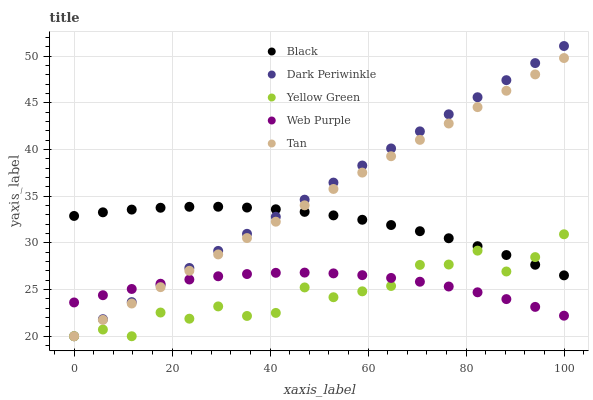Does Yellow Green have the minimum area under the curve?
Answer yes or no. Yes. Does Dark Periwinkle have the maximum area under the curve?
Answer yes or no. Yes. Does Web Purple have the minimum area under the curve?
Answer yes or no. No. Does Web Purple have the maximum area under the curve?
Answer yes or no. No. Is Dark Periwinkle the smoothest?
Answer yes or no. Yes. Is Yellow Green the roughest?
Answer yes or no. Yes. Is Web Purple the smoothest?
Answer yes or no. No. Is Web Purple the roughest?
Answer yes or no. No. Does Tan have the lowest value?
Answer yes or no. Yes. Does Web Purple have the lowest value?
Answer yes or no. No. Does Dark Periwinkle have the highest value?
Answer yes or no. Yes. Does Black have the highest value?
Answer yes or no. No. Is Web Purple less than Black?
Answer yes or no. Yes. Is Black greater than Web Purple?
Answer yes or no. Yes. Does Web Purple intersect Tan?
Answer yes or no. Yes. Is Web Purple less than Tan?
Answer yes or no. No. Is Web Purple greater than Tan?
Answer yes or no. No. Does Web Purple intersect Black?
Answer yes or no. No. 